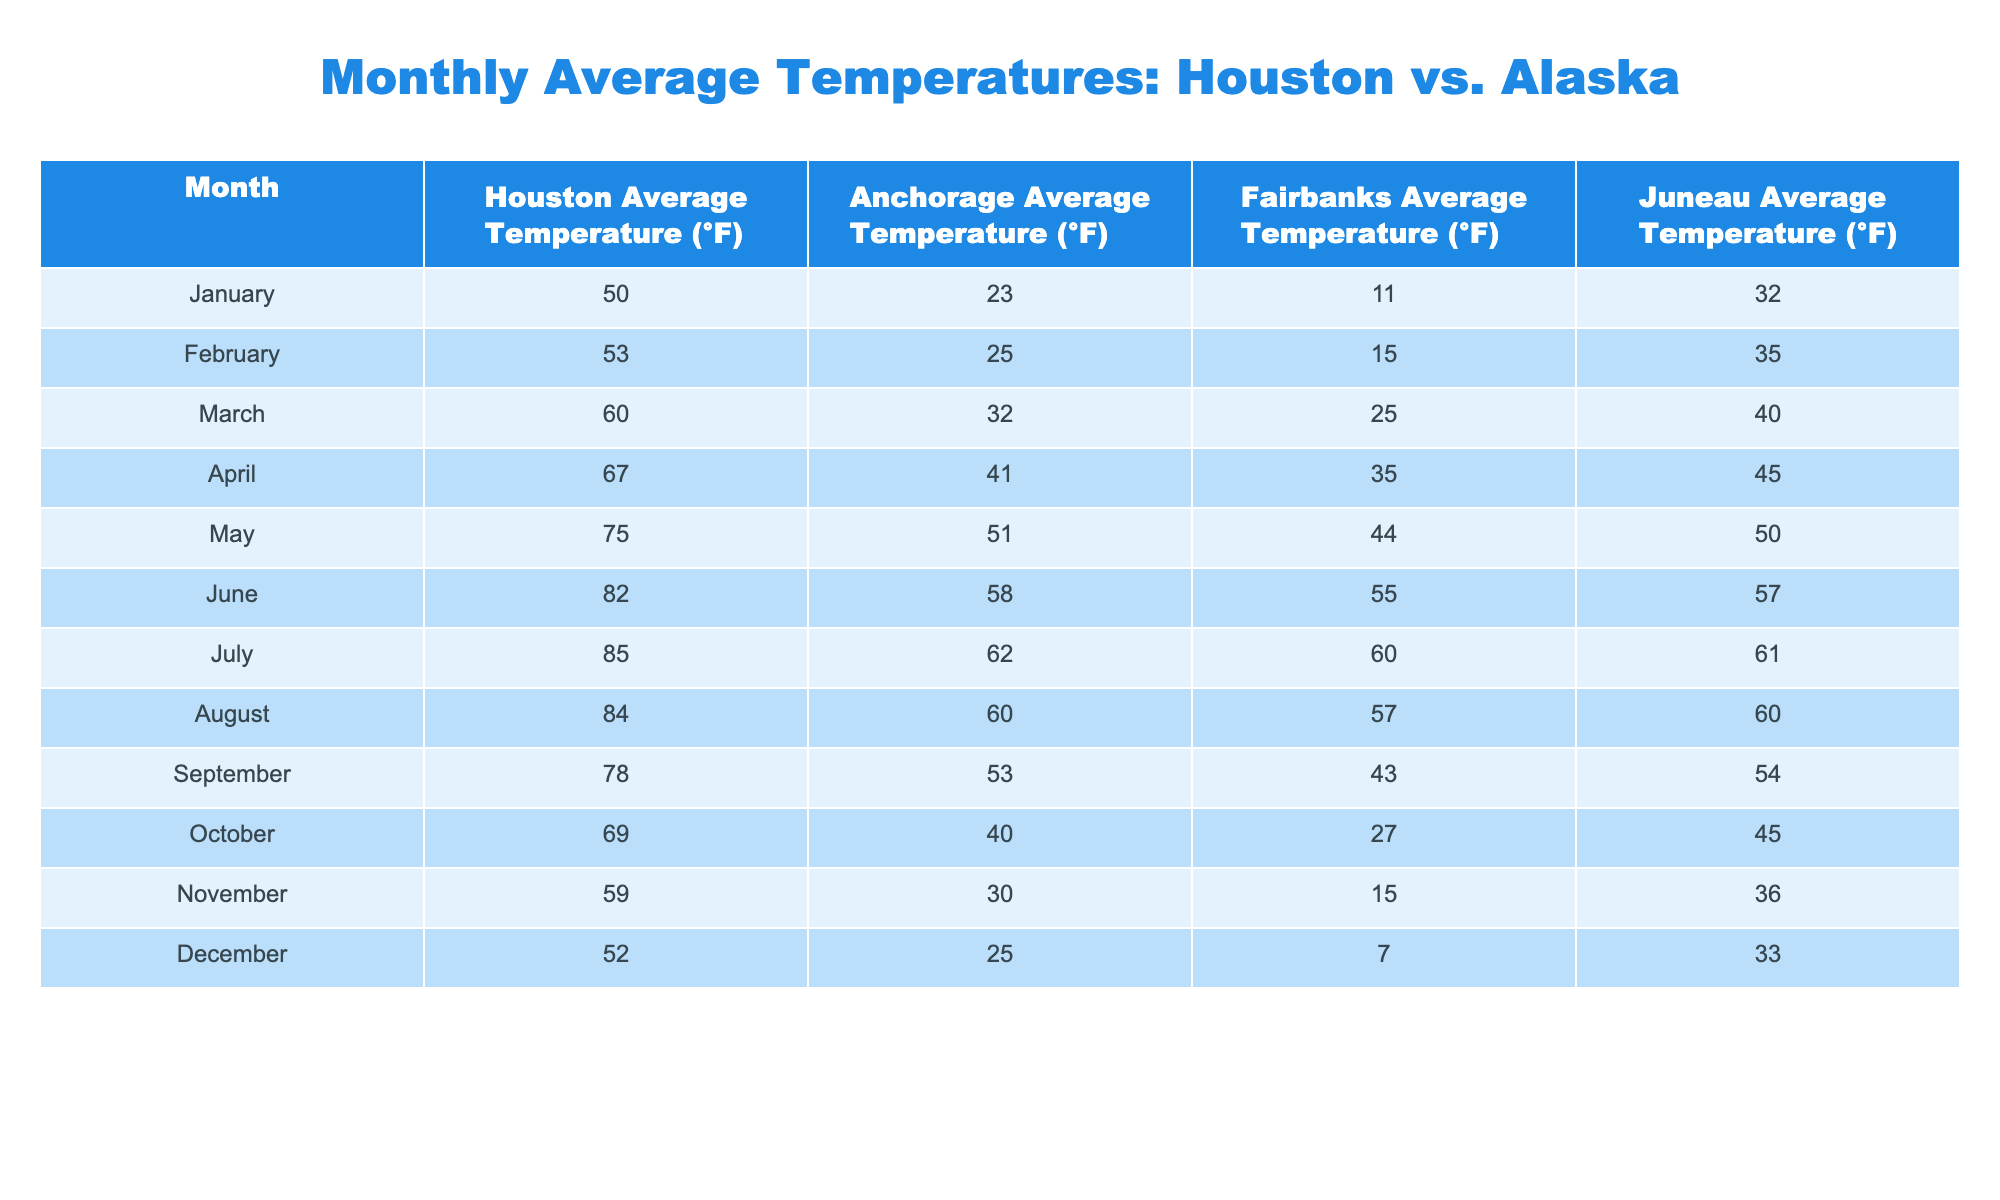What is the average temperature in Houston for July? Looking at the table, the average temperature in Houston for July is directly stated as 85°F.
Answer: 85°F Which month has the lowest average temperature in Fairbanks? Scanning through the Fairbanks column in the table, the lowest average temperature is found in December, which is 7°F.
Answer: 7°F What is the difference in average temperature between June in Houston and Anchorage? For June, Houston has an average temperature of 82°F, and Anchorage has 58°F. The difference is calculated as 82 - 58 = 24°F.
Answer: 24°F In which month does Anchorage experience an average temperature of 32°F? Referring to the table, Anchorage has an average temperature of 32°F in March.
Answer: March What are the average temperatures for Juneau in the winter months? The winter months are December, January, and February. Their average temperatures for Juneau are: December 33°F, January 32°F, and February 35°F. Average of these is (33 + 32 + 35)/3 = 33.33°F.
Answer: 33.33°F Is the average temperature in Anchorage higher than in Houston for April? Looking at the table, Anchorage shows an average temperature of 41°F, while Houston is at 67°F. Since 41°F is less than 67°F, the answer is no.
Answer: No Which city has the highest average temperature in August, and what is that temperature? In August, Houston has an average temperature of 84°F, while Anchorage's average is 60°F. Thus, Houston has the highest average temperature of 84°F in August.
Answer: Houston, 84°F What is the average of the Houston average temperatures from January to March? The temperatures are 50°F (January), 53°F (February), and 60°F (March). Summing these gives 50 + 53 + 60 = 163°F. The average is 163°F / 3 = 54.33°F.
Answer: 54.33°F How many months have an average temperature below 30°F in any city? Checking each city, Fairbanks has below 30°F in January (11°F), November (15°F), and December (7°F), totaling three months. Anchorage has January and February below 30°F, making it five total months across all cities.
Answer: 5 months What is the highest average temperature recorded in Juneau and in which month does it occur? Scanning the Juneau column, the highest average temperature is 57°F in June.
Answer: 57°F in June 